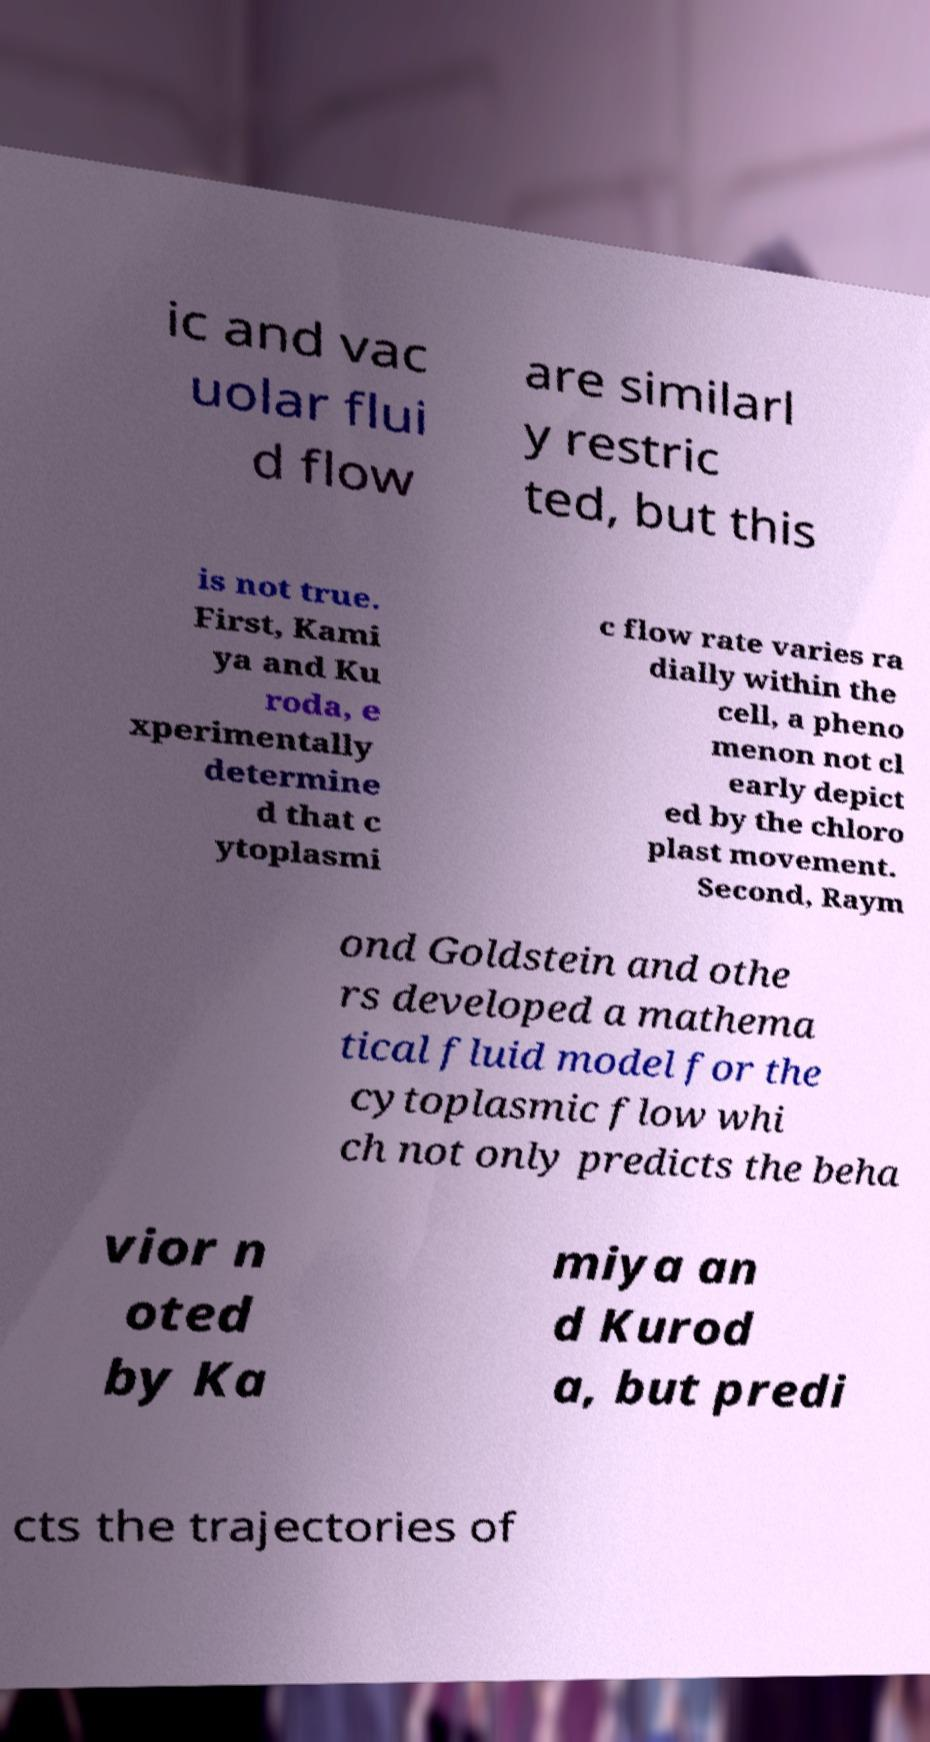For documentation purposes, I need the text within this image transcribed. Could you provide that? ic and vac uolar flui d flow are similarl y restric ted, but this is not true. First, Kami ya and Ku roda, e xperimentally determine d that c ytoplasmi c flow rate varies ra dially within the cell, a pheno menon not cl early depict ed by the chloro plast movement. Second, Raym ond Goldstein and othe rs developed a mathema tical fluid model for the cytoplasmic flow whi ch not only predicts the beha vior n oted by Ka miya an d Kurod a, but predi cts the trajectories of 